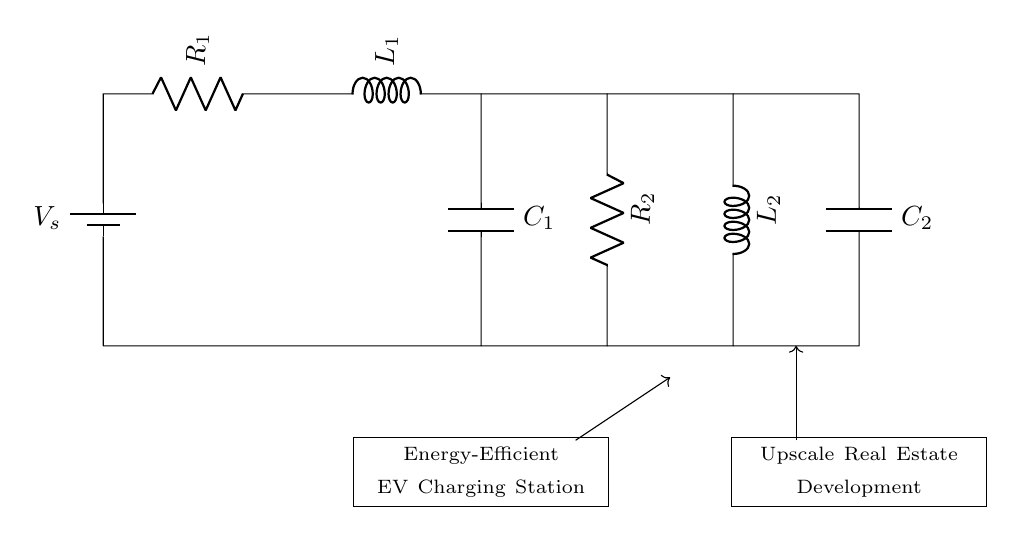what type of components are shown in this circuit? The circuit contains resistors, inductors, and capacitors, which are typical components of an RLC circuit.
Answer: resistors, inductors, capacitors how many resistors are in the circuit? The circuit shows two resistors (R1 and R2) depicted in the diagram.
Answer: two what is the role of the inductor in this circuit? The inductor (L1 and L2) stores energy in a magnetic field when electrical current passes through it, which helps in managing current fluctuations during charging.
Answer: stores energy how does the presence of capacitors affect energy efficiency in this circuit? Capacitors (C1 and C2) smooth out the charging process by storing and releasing energy, reducing ripple and improving the overall efficiency during the electric vehicle charging.
Answer: smooths charging what is the expected relationship between resistors, inductors, and capacitors in the context of energy-efficient charging? The resistors control current flow and power dissipation, while inductors and capacitors work together to regulate voltage and store energy, optimizing the charging process.
Answer: regulates voltage and stores energy which components are connected in series in this circuit? Resistors R1, R2, inductors L1, L2, and capacitors C1, C2 are connected in series, forming a sequential path for current flow.
Answer: R1, L1, C1, R2, L2, C2 how do the inductors help in protecting the circuit? Inductors help in filtering out sudden changes in current, protecting sensitive components from voltage spikes during the energy transfer process.
Answer: filters current spikes 